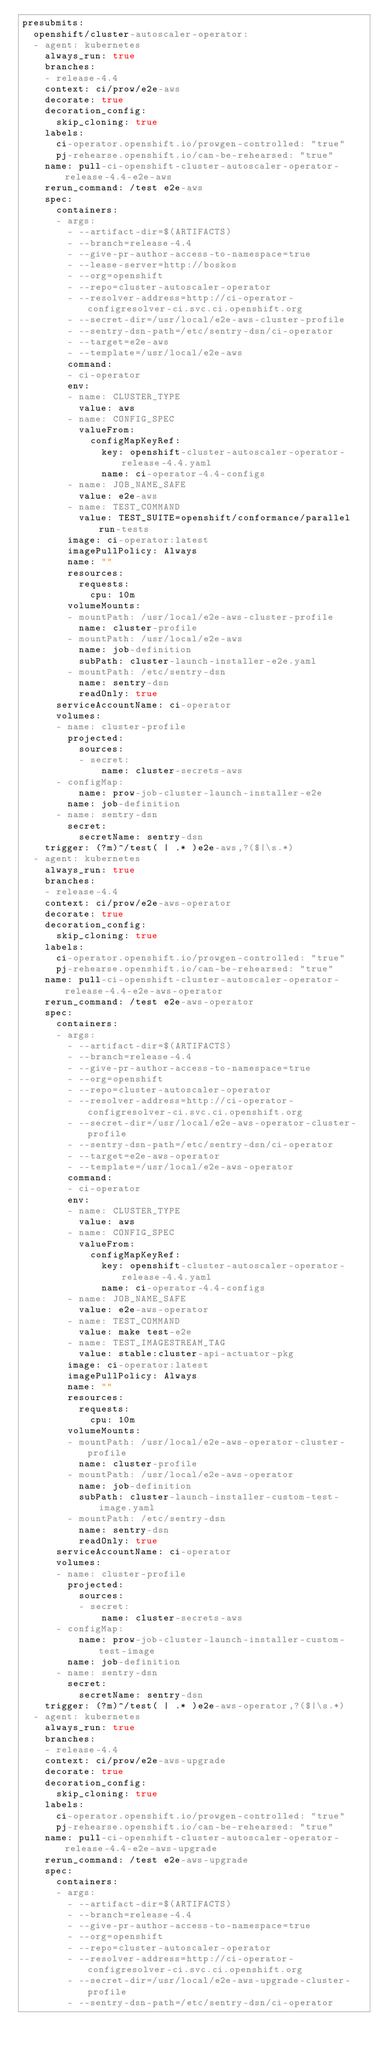Convert code to text. <code><loc_0><loc_0><loc_500><loc_500><_YAML_>presubmits:
  openshift/cluster-autoscaler-operator:
  - agent: kubernetes
    always_run: true
    branches:
    - release-4.4
    context: ci/prow/e2e-aws
    decorate: true
    decoration_config:
      skip_cloning: true
    labels:
      ci-operator.openshift.io/prowgen-controlled: "true"
      pj-rehearse.openshift.io/can-be-rehearsed: "true"
    name: pull-ci-openshift-cluster-autoscaler-operator-release-4.4-e2e-aws
    rerun_command: /test e2e-aws
    spec:
      containers:
      - args:
        - --artifact-dir=$(ARTIFACTS)
        - --branch=release-4.4
        - --give-pr-author-access-to-namespace=true
        - --lease-server=http://boskos
        - --org=openshift
        - --repo=cluster-autoscaler-operator
        - --resolver-address=http://ci-operator-configresolver-ci.svc.ci.openshift.org
        - --secret-dir=/usr/local/e2e-aws-cluster-profile
        - --sentry-dsn-path=/etc/sentry-dsn/ci-operator
        - --target=e2e-aws
        - --template=/usr/local/e2e-aws
        command:
        - ci-operator
        env:
        - name: CLUSTER_TYPE
          value: aws
        - name: CONFIG_SPEC
          valueFrom:
            configMapKeyRef:
              key: openshift-cluster-autoscaler-operator-release-4.4.yaml
              name: ci-operator-4.4-configs
        - name: JOB_NAME_SAFE
          value: e2e-aws
        - name: TEST_COMMAND
          value: TEST_SUITE=openshift/conformance/parallel run-tests
        image: ci-operator:latest
        imagePullPolicy: Always
        name: ""
        resources:
          requests:
            cpu: 10m
        volumeMounts:
        - mountPath: /usr/local/e2e-aws-cluster-profile
          name: cluster-profile
        - mountPath: /usr/local/e2e-aws
          name: job-definition
          subPath: cluster-launch-installer-e2e.yaml
        - mountPath: /etc/sentry-dsn
          name: sentry-dsn
          readOnly: true
      serviceAccountName: ci-operator
      volumes:
      - name: cluster-profile
        projected:
          sources:
          - secret:
              name: cluster-secrets-aws
      - configMap:
          name: prow-job-cluster-launch-installer-e2e
        name: job-definition
      - name: sentry-dsn
        secret:
          secretName: sentry-dsn
    trigger: (?m)^/test( | .* )e2e-aws,?($|\s.*)
  - agent: kubernetes
    always_run: true
    branches:
    - release-4.4
    context: ci/prow/e2e-aws-operator
    decorate: true
    decoration_config:
      skip_cloning: true
    labels:
      ci-operator.openshift.io/prowgen-controlled: "true"
      pj-rehearse.openshift.io/can-be-rehearsed: "true"
    name: pull-ci-openshift-cluster-autoscaler-operator-release-4.4-e2e-aws-operator
    rerun_command: /test e2e-aws-operator
    spec:
      containers:
      - args:
        - --artifact-dir=$(ARTIFACTS)
        - --branch=release-4.4
        - --give-pr-author-access-to-namespace=true
        - --org=openshift
        - --repo=cluster-autoscaler-operator
        - --resolver-address=http://ci-operator-configresolver-ci.svc.ci.openshift.org
        - --secret-dir=/usr/local/e2e-aws-operator-cluster-profile
        - --sentry-dsn-path=/etc/sentry-dsn/ci-operator
        - --target=e2e-aws-operator
        - --template=/usr/local/e2e-aws-operator
        command:
        - ci-operator
        env:
        - name: CLUSTER_TYPE
          value: aws
        - name: CONFIG_SPEC
          valueFrom:
            configMapKeyRef:
              key: openshift-cluster-autoscaler-operator-release-4.4.yaml
              name: ci-operator-4.4-configs
        - name: JOB_NAME_SAFE
          value: e2e-aws-operator
        - name: TEST_COMMAND
          value: make test-e2e
        - name: TEST_IMAGESTREAM_TAG
          value: stable:cluster-api-actuator-pkg
        image: ci-operator:latest
        imagePullPolicy: Always
        name: ""
        resources:
          requests:
            cpu: 10m
        volumeMounts:
        - mountPath: /usr/local/e2e-aws-operator-cluster-profile
          name: cluster-profile
        - mountPath: /usr/local/e2e-aws-operator
          name: job-definition
          subPath: cluster-launch-installer-custom-test-image.yaml
        - mountPath: /etc/sentry-dsn
          name: sentry-dsn
          readOnly: true
      serviceAccountName: ci-operator
      volumes:
      - name: cluster-profile
        projected:
          sources:
          - secret:
              name: cluster-secrets-aws
      - configMap:
          name: prow-job-cluster-launch-installer-custom-test-image
        name: job-definition
      - name: sentry-dsn
        secret:
          secretName: sentry-dsn
    trigger: (?m)^/test( | .* )e2e-aws-operator,?($|\s.*)
  - agent: kubernetes
    always_run: true
    branches:
    - release-4.4
    context: ci/prow/e2e-aws-upgrade
    decorate: true
    decoration_config:
      skip_cloning: true
    labels:
      ci-operator.openshift.io/prowgen-controlled: "true"
      pj-rehearse.openshift.io/can-be-rehearsed: "true"
    name: pull-ci-openshift-cluster-autoscaler-operator-release-4.4-e2e-aws-upgrade
    rerun_command: /test e2e-aws-upgrade
    spec:
      containers:
      - args:
        - --artifact-dir=$(ARTIFACTS)
        - --branch=release-4.4
        - --give-pr-author-access-to-namespace=true
        - --org=openshift
        - --repo=cluster-autoscaler-operator
        - --resolver-address=http://ci-operator-configresolver-ci.svc.ci.openshift.org
        - --secret-dir=/usr/local/e2e-aws-upgrade-cluster-profile
        - --sentry-dsn-path=/etc/sentry-dsn/ci-operator</code> 